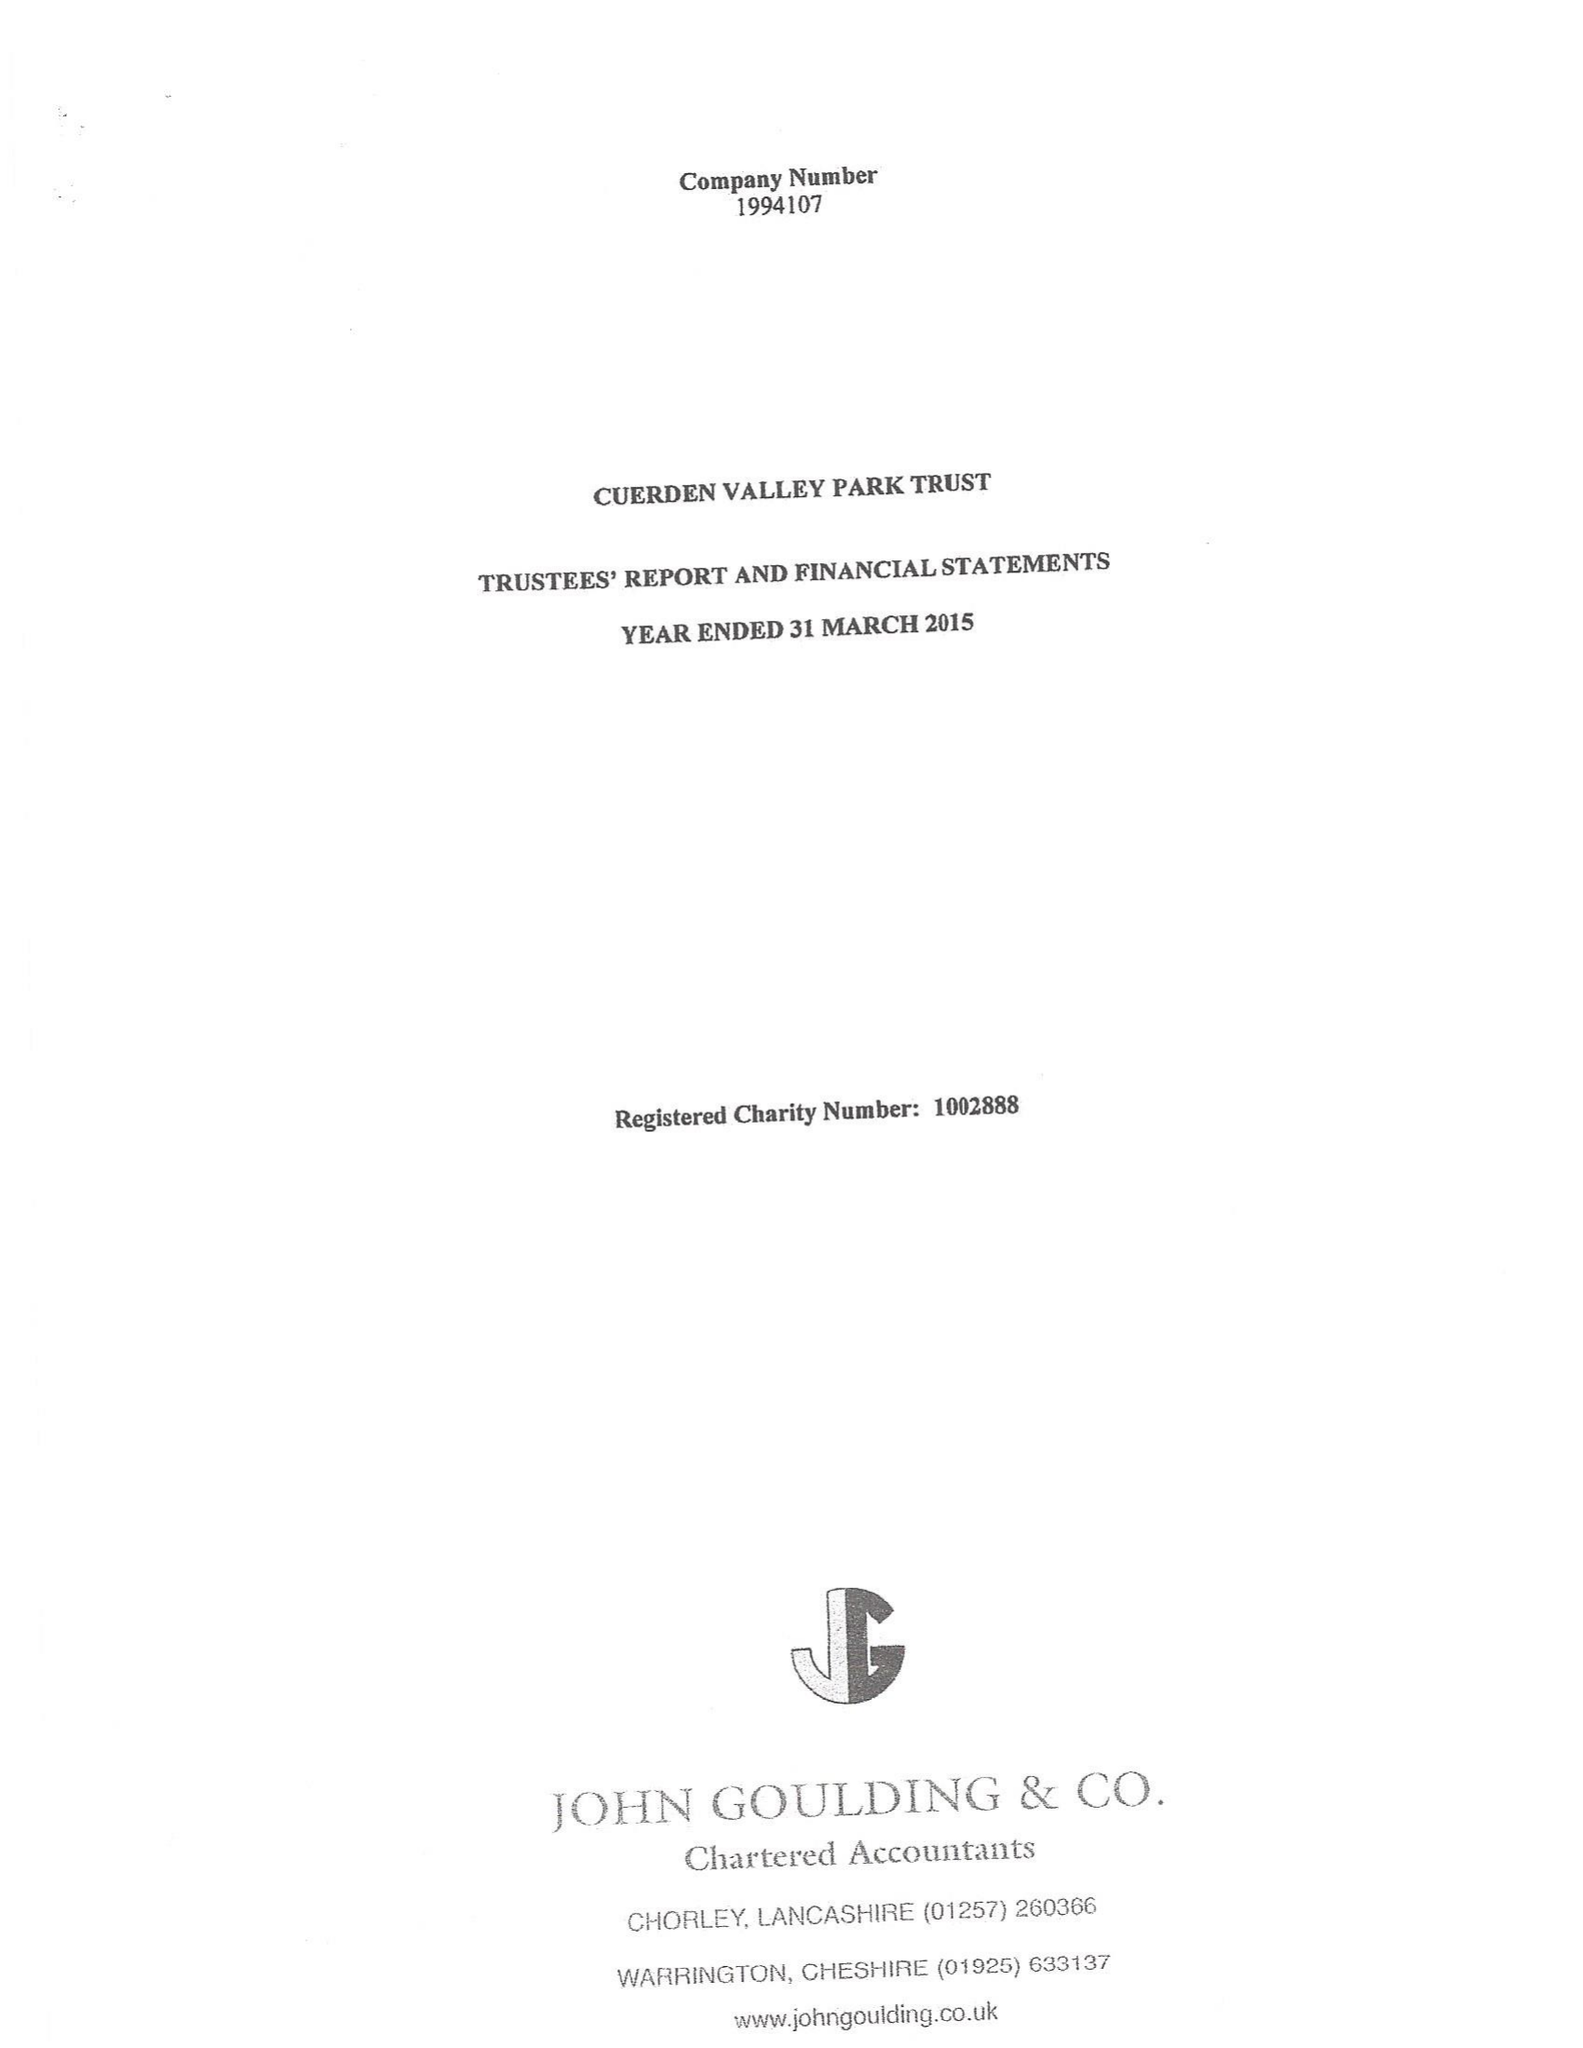What is the value for the address__post_town?
Answer the question using a single word or phrase. PRESTON 